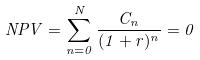Convert formula to latex. <formula><loc_0><loc_0><loc_500><loc_500>N P V = \sum _ { n = 0 } ^ { N } \frac { C _ { n } } { ( 1 + r ) ^ { n } } = 0</formula> 